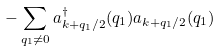Convert formula to latex. <formula><loc_0><loc_0><loc_500><loc_500>- \sum _ { { q _ { 1 } } \neq 0 } a ^ { \dagger } _ { { k + q _ { 1 } / 2 } } ( { q } _ { 1 } ) a _ { { k + q _ { 1 } / 2 } } ( { q } _ { 1 } )</formula> 